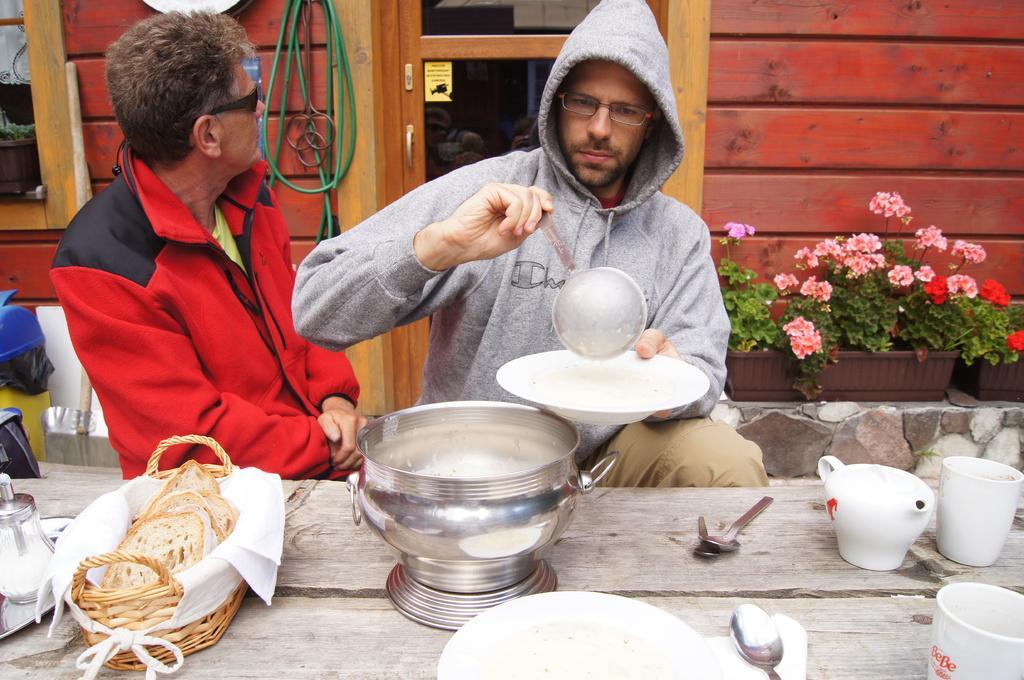Can you describe this image briefly? At the bottom of the image there is a table with vessel, plates, spoons, kettle, glasses and some other items. Behind the table there is a man sitting and holding a plate in one hand. And in the other hand there is a spoon. Beside him there is a man with goggles. Behind them there is a pot with leaves and flowers. And also there is a wall with glass door, windows and a pipe. 